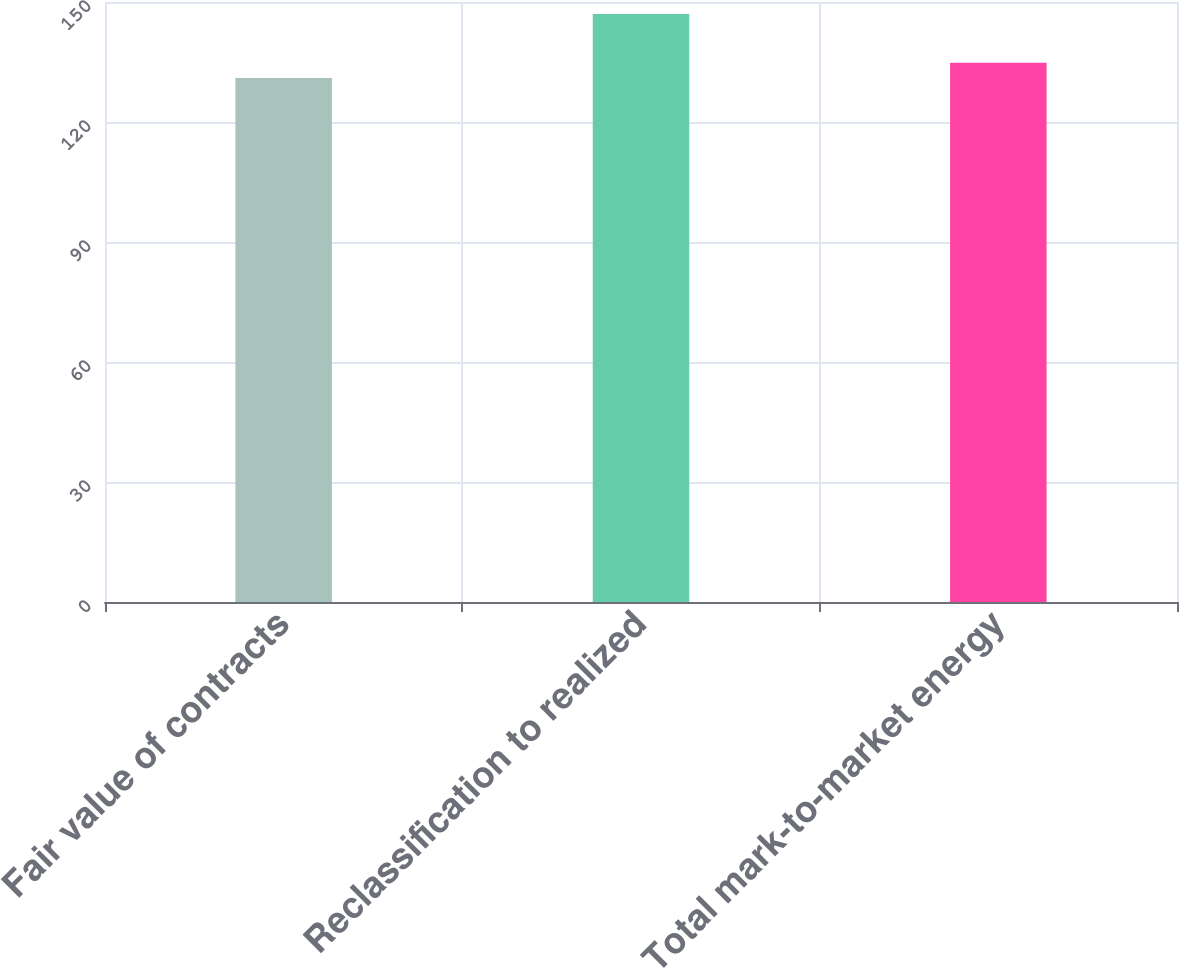<chart> <loc_0><loc_0><loc_500><loc_500><bar_chart><fcel>Fair value of contracts<fcel>Reclassification to realized<fcel>Total mark-to-market energy<nl><fcel>131<fcel>147<fcel>134.8<nl></chart> 